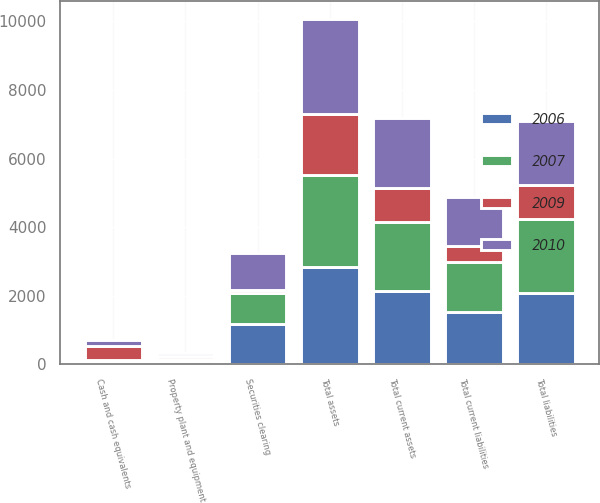Convert chart to OTSL. <chart><loc_0><loc_0><loc_500><loc_500><stacked_bar_chart><ecel><fcel>Cash and cash equivalents<fcel>Securities clearing<fcel>Total current assets<fcel>Property plant and equipment<fcel>Total assets<fcel>Total current liabilities<fcel>Total liabilities<nl><fcel>2009<fcel>412.6<fcel>77.4<fcel>992.4<fcel>87.4<fcel>1794.4<fcel>475.2<fcel>987.3<nl><fcel>2010<fcel>173.4<fcel>1088.1<fcel>2051.8<fcel>75.4<fcel>2774.7<fcel>1429.9<fcel>1865.7<nl><fcel>2006<fcel>54.7<fcel>1157.4<fcel>2131.8<fcel>82.6<fcel>2833.6<fcel>1532.2<fcel>2087.8<nl><fcel>2007<fcel>72.2<fcel>915.4<fcel>2013.7<fcel>77.4<fcel>2678.2<fcel>1433.2<fcel>2147.1<nl></chart> 